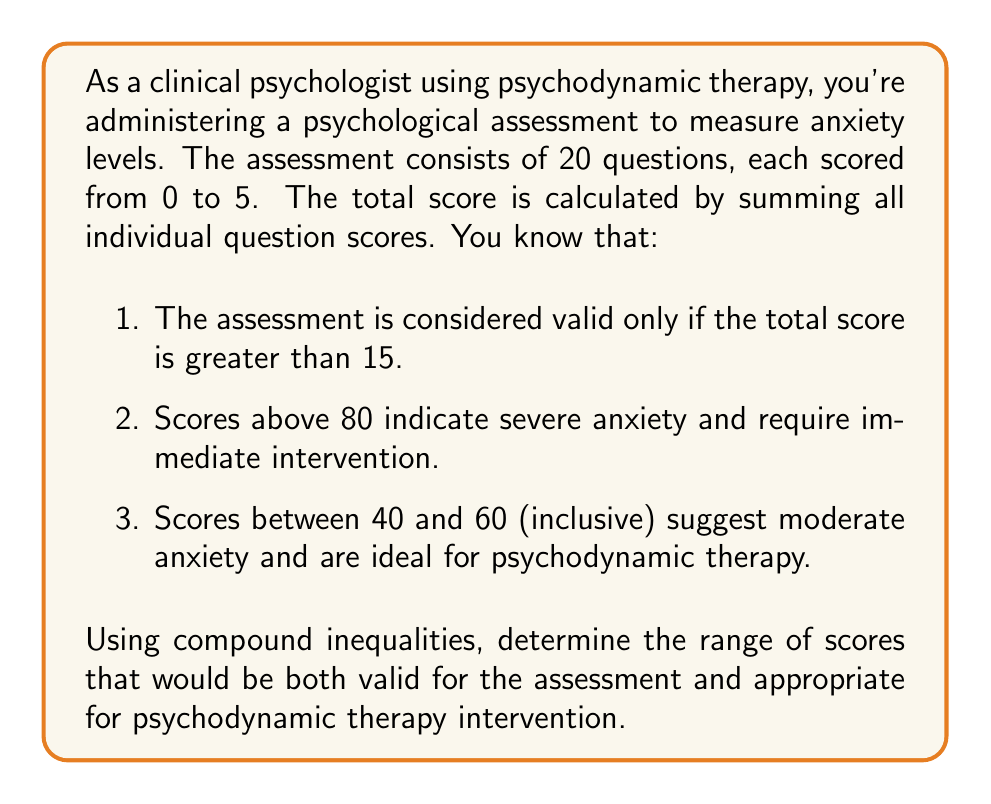Could you help me with this problem? Let's approach this step-by-step:

1. First, we need to establish the possible range of total scores:
   - Minimum possible score: $20 \times 0 = 0$
   - Maximum possible score: $20 \times 5 = 100$

2. Now, let's express the conditions as inequalities:
   - Valid assessment: $\text{Score} > 15$
   - Not severe anxiety: $\text{Score} \leq 80$
   - Moderate anxiety (ideal for psychodynamic therapy): $40 \leq \text{Score} \leq 60$

3. Combining these conditions using compound inequalities:
   $$ 15 < \text{Score} \leq 60 \text{ AND } 40 \leq \text{Score} \leq 80 $$

4. Simplifying the compound inequality:
   - The lower bound is the maximum of 15 and 40, which is 40.
   - The upper bound is the minimum of 60 and 80, which is 60.

5. Therefore, the final compound inequality is:
   $$ 40 \leq \text{Score} \leq 60 $$

This range satisfies all the given conditions: it's valid (>15), not severe (≤80), and within the moderate anxiety range ideal for psychodynamic therapy.
Answer: The range of scores that are both valid for the assessment and appropriate for psychodynamic therapy intervention is $40 \leq \text{Score} \leq 60$. 